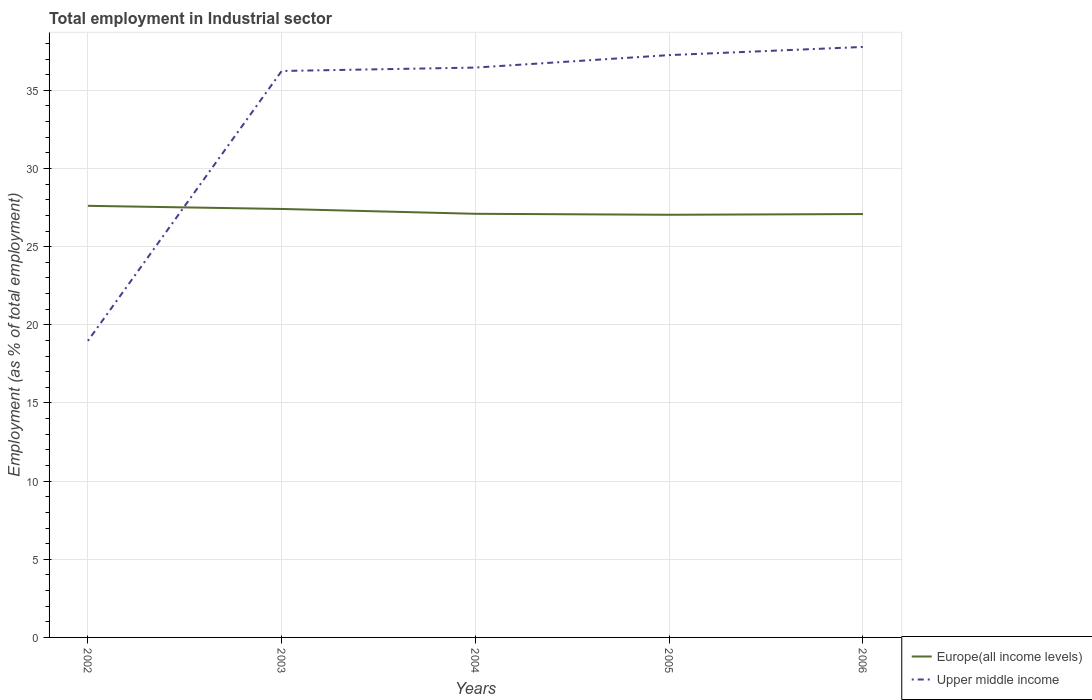Across all years, what is the maximum employment in industrial sector in Upper middle income?
Give a very brief answer. 18.97. What is the total employment in industrial sector in Upper middle income in the graph?
Make the answer very short. -18.81. What is the difference between the highest and the second highest employment in industrial sector in Europe(all income levels)?
Ensure brevity in your answer.  0.57. Is the employment in industrial sector in Europe(all income levels) strictly greater than the employment in industrial sector in Upper middle income over the years?
Provide a short and direct response. No. Are the values on the major ticks of Y-axis written in scientific E-notation?
Keep it short and to the point. No. How are the legend labels stacked?
Offer a terse response. Vertical. What is the title of the graph?
Ensure brevity in your answer.  Total employment in Industrial sector. What is the label or title of the Y-axis?
Provide a succinct answer. Employment (as % of total employment). What is the Employment (as % of total employment) of Europe(all income levels) in 2002?
Offer a terse response. 27.61. What is the Employment (as % of total employment) in Upper middle income in 2002?
Give a very brief answer. 18.97. What is the Employment (as % of total employment) of Europe(all income levels) in 2003?
Make the answer very short. 27.41. What is the Employment (as % of total employment) in Upper middle income in 2003?
Offer a very short reply. 36.24. What is the Employment (as % of total employment) in Europe(all income levels) in 2004?
Provide a succinct answer. 27.1. What is the Employment (as % of total employment) of Upper middle income in 2004?
Your answer should be very brief. 36.46. What is the Employment (as % of total employment) of Europe(all income levels) in 2005?
Give a very brief answer. 27.04. What is the Employment (as % of total employment) of Upper middle income in 2005?
Keep it short and to the point. 37.26. What is the Employment (as % of total employment) of Europe(all income levels) in 2006?
Offer a terse response. 27.09. What is the Employment (as % of total employment) of Upper middle income in 2006?
Provide a short and direct response. 37.78. Across all years, what is the maximum Employment (as % of total employment) in Europe(all income levels)?
Your response must be concise. 27.61. Across all years, what is the maximum Employment (as % of total employment) in Upper middle income?
Make the answer very short. 37.78. Across all years, what is the minimum Employment (as % of total employment) of Europe(all income levels)?
Offer a very short reply. 27.04. Across all years, what is the minimum Employment (as % of total employment) of Upper middle income?
Provide a short and direct response. 18.97. What is the total Employment (as % of total employment) of Europe(all income levels) in the graph?
Offer a very short reply. 136.25. What is the total Employment (as % of total employment) in Upper middle income in the graph?
Offer a very short reply. 166.7. What is the difference between the Employment (as % of total employment) of Europe(all income levels) in 2002 and that in 2003?
Your answer should be compact. 0.2. What is the difference between the Employment (as % of total employment) of Upper middle income in 2002 and that in 2003?
Your answer should be very brief. -17.27. What is the difference between the Employment (as % of total employment) of Europe(all income levels) in 2002 and that in 2004?
Your answer should be compact. 0.51. What is the difference between the Employment (as % of total employment) in Upper middle income in 2002 and that in 2004?
Ensure brevity in your answer.  -17.49. What is the difference between the Employment (as % of total employment) in Europe(all income levels) in 2002 and that in 2005?
Your response must be concise. 0.57. What is the difference between the Employment (as % of total employment) in Upper middle income in 2002 and that in 2005?
Provide a short and direct response. -18.28. What is the difference between the Employment (as % of total employment) in Europe(all income levels) in 2002 and that in 2006?
Ensure brevity in your answer.  0.53. What is the difference between the Employment (as % of total employment) in Upper middle income in 2002 and that in 2006?
Provide a short and direct response. -18.81. What is the difference between the Employment (as % of total employment) of Europe(all income levels) in 2003 and that in 2004?
Keep it short and to the point. 0.31. What is the difference between the Employment (as % of total employment) in Upper middle income in 2003 and that in 2004?
Provide a succinct answer. -0.22. What is the difference between the Employment (as % of total employment) of Europe(all income levels) in 2003 and that in 2005?
Offer a terse response. 0.37. What is the difference between the Employment (as % of total employment) in Upper middle income in 2003 and that in 2005?
Offer a very short reply. -1.02. What is the difference between the Employment (as % of total employment) in Europe(all income levels) in 2003 and that in 2006?
Your answer should be compact. 0.33. What is the difference between the Employment (as % of total employment) of Upper middle income in 2003 and that in 2006?
Provide a short and direct response. -1.54. What is the difference between the Employment (as % of total employment) of Europe(all income levels) in 2004 and that in 2005?
Offer a very short reply. 0.06. What is the difference between the Employment (as % of total employment) of Upper middle income in 2004 and that in 2005?
Provide a short and direct response. -0.8. What is the difference between the Employment (as % of total employment) in Europe(all income levels) in 2004 and that in 2006?
Make the answer very short. 0.02. What is the difference between the Employment (as % of total employment) of Upper middle income in 2004 and that in 2006?
Provide a short and direct response. -1.32. What is the difference between the Employment (as % of total employment) of Europe(all income levels) in 2005 and that in 2006?
Provide a short and direct response. -0.05. What is the difference between the Employment (as % of total employment) of Upper middle income in 2005 and that in 2006?
Give a very brief answer. -0.52. What is the difference between the Employment (as % of total employment) in Europe(all income levels) in 2002 and the Employment (as % of total employment) in Upper middle income in 2003?
Your answer should be compact. -8.63. What is the difference between the Employment (as % of total employment) of Europe(all income levels) in 2002 and the Employment (as % of total employment) of Upper middle income in 2004?
Your answer should be very brief. -8.85. What is the difference between the Employment (as % of total employment) of Europe(all income levels) in 2002 and the Employment (as % of total employment) of Upper middle income in 2005?
Your answer should be compact. -9.64. What is the difference between the Employment (as % of total employment) of Europe(all income levels) in 2002 and the Employment (as % of total employment) of Upper middle income in 2006?
Give a very brief answer. -10.17. What is the difference between the Employment (as % of total employment) of Europe(all income levels) in 2003 and the Employment (as % of total employment) of Upper middle income in 2004?
Your answer should be very brief. -9.04. What is the difference between the Employment (as % of total employment) in Europe(all income levels) in 2003 and the Employment (as % of total employment) in Upper middle income in 2005?
Ensure brevity in your answer.  -9.84. What is the difference between the Employment (as % of total employment) in Europe(all income levels) in 2003 and the Employment (as % of total employment) in Upper middle income in 2006?
Make the answer very short. -10.36. What is the difference between the Employment (as % of total employment) in Europe(all income levels) in 2004 and the Employment (as % of total employment) in Upper middle income in 2005?
Provide a succinct answer. -10.15. What is the difference between the Employment (as % of total employment) of Europe(all income levels) in 2004 and the Employment (as % of total employment) of Upper middle income in 2006?
Ensure brevity in your answer.  -10.67. What is the difference between the Employment (as % of total employment) of Europe(all income levels) in 2005 and the Employment (as % of total employment) of Upper middle income in 2006?
Your answer should be very brief. -10.74. What is the average Employment (as % of total employment) in Europe(all income levels) per year?
Keep it short and to the point. 27.25. What is the average Employment (as % of total employment) in Upper middle income per year?
Keep it short and to the point. 33.34. In the year 2002, what is the difference between the Employment (as % of total employment) of Europe(all income levels) and Employment (as % of total employment) of Upper middle income?
Your answer should be compact. 8.64. In the year 2003, what is the difference between the Employment (as % of total employment) in Europe(all income levels) and Employment (as % of total employment) in Upper middle income?
Your response must be concise. -8.83. In the year 2004, what is the difference between the Employment (as % of total employment) of Europe(all income levels) and Employment (as % of total employment) of Upper middle income?
Offer a very short reply. -9.35. In the year 2005, what is the difference between the Employment (as % of total employment) in Europe(all income levels) and Employment (as % of total employment) in Upper middle income?
Give a very brief answer. -10.21. In the year 2006, what is the difference between the Employment (as % of total employment) in Europe(all income levels) and Employment (as % of total employment) in Upper middle income?
Your answer should be compact. -10.69. What is the ratio of the Employment (as % of total employment) of Europe(all income levels) in 2002 to that in 2003?
Your response must be concise. 1.01. What is the ratio of the Employment (as % of total employment) in Upper middle income in 2002 to that in 2003?
Offer a very short reply. 0.52. What is the ratio of the Employment (as % of total employment) of Europe(all income levels) in 2002 to that in 2004?
Give a very brief answer. 1.02. What is the ratio of the Employment (as % of total employment) of Upper middle income in 2002 to that in 2004?
Your answer should be compact. 0.52. What is the ratio of the Employment (as % of total employment) in Europe(all income levels) in 2002 to that in 2005?
Provide a short and direct response. 1.02. What is the ratio of the Employment (as % of total employment) of Upper middle income in 2002 to that in 2005?
Keep it short and to the point. 0.51. What is the ratio of the Employment (as % of total employment) in Europe(all income levels) in 2002 to that in 2006?
Give a very brief answer. 1.02. What is the ratio of the Employment (as % of total employment) in Upper middle income in 2002 to that in 2006?
Provide a succinct answer. 0.5. What is the ratio of the Employment (as % of total employment) of Europe(all income levels) in 2003 to that in 2004?
Your answer should be very brief. 1.01. What is the ratio of the Employment (as % of total employment) in Upper middle income in 2003 to that in 2004?
Offer a very short reply. 0.99. What is the ratio of the Employment (as % of total employment) in Europe(all income levels) in 2003 to that in 2005?
Make the answer very short. 1.01. What is the ratio of the Employment (as % of total employment) in Upper middle income in 2003 to that in 2005?
Your answer should be compact. 0.97. What is the ratio of the Employment (as % of total employment) in Europe(all income levels) in 2003 to that in 2006?
Your answer should be very brief. 1.01. What is the ratio of the Employment (as % of total employment) of Upper middle income in 2003 to that in 2006?
Offer a very short reply. 0.96. What is the ratio of the Employment (as % of total employment) of Europe(all income levels) in 2004 to that in 2005?
Provide a succinct answer. 1. What is the ratio of the Employment (as % of total employment) in Upper middle income in 2004 to that in 2005?
Your answer should be very brief. 0.98. What is the ratio of the Employment (as % of total employment) of Upper middle income in 2004 to that in 2006?
Provide a succinct answer. 0.97. What is the ratio of the Employment (as % of total employment) in Europe(all income levels) in 2005 to that in 2006?
Give a very brief answer. 1. What is the ratio of the Employment (as % of total employment) in Upper middle income in 2005 to that in 2006?
Make the answer very short. 0.99. What is the difference between the highest and the second highest Employment (as % of total employment) of Europe(all income levels)?
Keep it short and to the point. 0.2. What is the difference between the highest and the second highest Employment (as % of total employment) of Upper middle income?
Your answer should be very brief. 0.52. What is the difference between the highest and the lowest Employment (as % of total employment) in Europe(all income levels)?
Ensure brevity in your answer.  0.57. What is the difference between the highest and the lowest Employment (as % of total employment) of Upper middle income?
Offer a terse response. 18.81. 